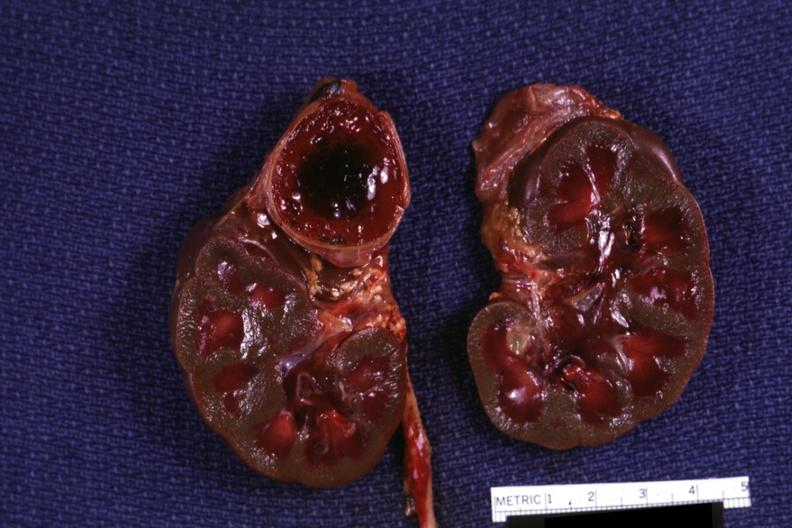does heart show section of both kidneys and adrenals hemorrhage on one side kidneys are jaundiced?
Answer the question using a single word or phrase. No 